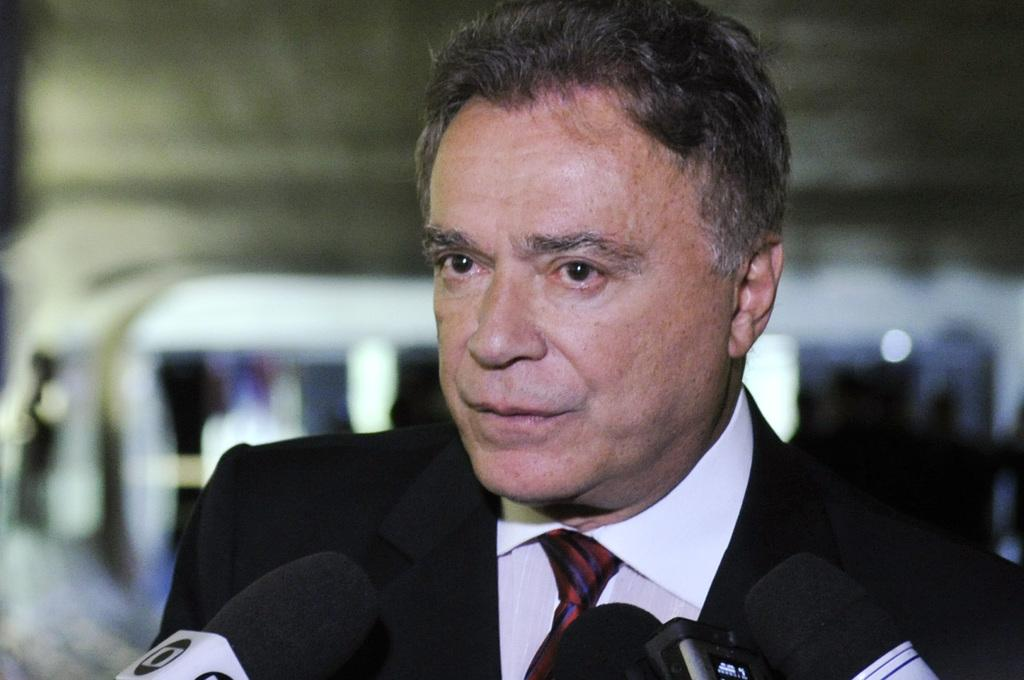Who is present in the image? There is a man in the image. What is the man wearing? The man is wearing a suit. What objects can be seen in the front of the image? There are microphones in the front of the image. Can you describe the background of the image? The background of the image is blurred. How much dirt is visible on the man's shoes in the image? There is no dirt visible on the man's shoes in the image, as the focus is on the man and the microphones, not his shoes. 